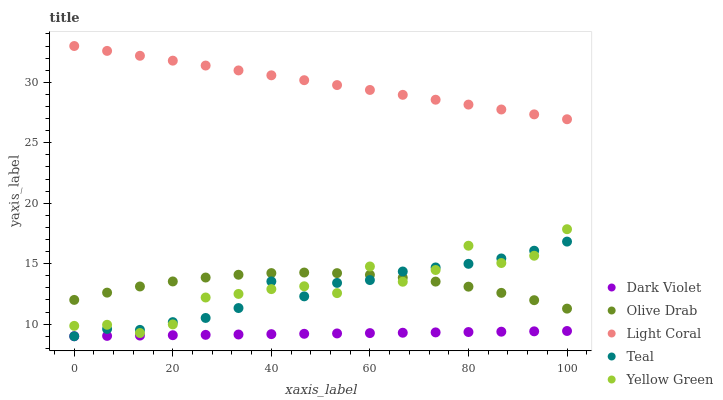Does Dark Violet have the minimum area under the curve?
Answer yes or no. Yes. Does Light Coral have the maximum area under the curve?
Answer yes or no. Yes. Does Teal have the minimum area under the curve?
Answer yes or no. No. Does Teal have the maximum area under the curve?
Answer yes or no. No. Is Dark Violet the smoothest?
Answer yes or no. Yes. Is Yellow Green the roughest?
Answer yes or no. Yes. Is Teal the smoothest?
Answer yes or no. No. Is Teal the roughest?
Answer yes or no. No. Does Teal have the lowest value?
Answer yes or no. Yes. Does Olive Drab have the lowest value?
Answer yes or no. No. Does Light Coral have the highest value?
Answer yes or no. Yes. Does Teal have the highest value?
Answer yes or no. No. Is Dark Violet less than Light Coral?
Answer yes or no. Yes. Is Yellow Green greater than Dark Violet?
Answer yes or no. Yes. Does Teal intersect Yellow Green?
Answer yes or no. Yes. Is Teal less than Yellow Green?
Answer yes or no. No. Is Teal greater than Yellow Green?
Answer yes or no. No. Does Dark Violet intersect Light Coral?
Answer yes or no. No. 